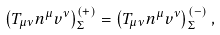Convert formula to latex. <formula><loc_0><loc_0><loc_500><loc_500>\left ( T _ { \mu \nu } n ^ { \mu } v ^ { \nu } \right ) ^ { ( + ) } _ { \Sigma } = \left ( T _ { \mu \nu } n ^ { \mu } v ^ { \nu } \right ) ^ { ( - ) } _ { \Sigma } ,</formula> 